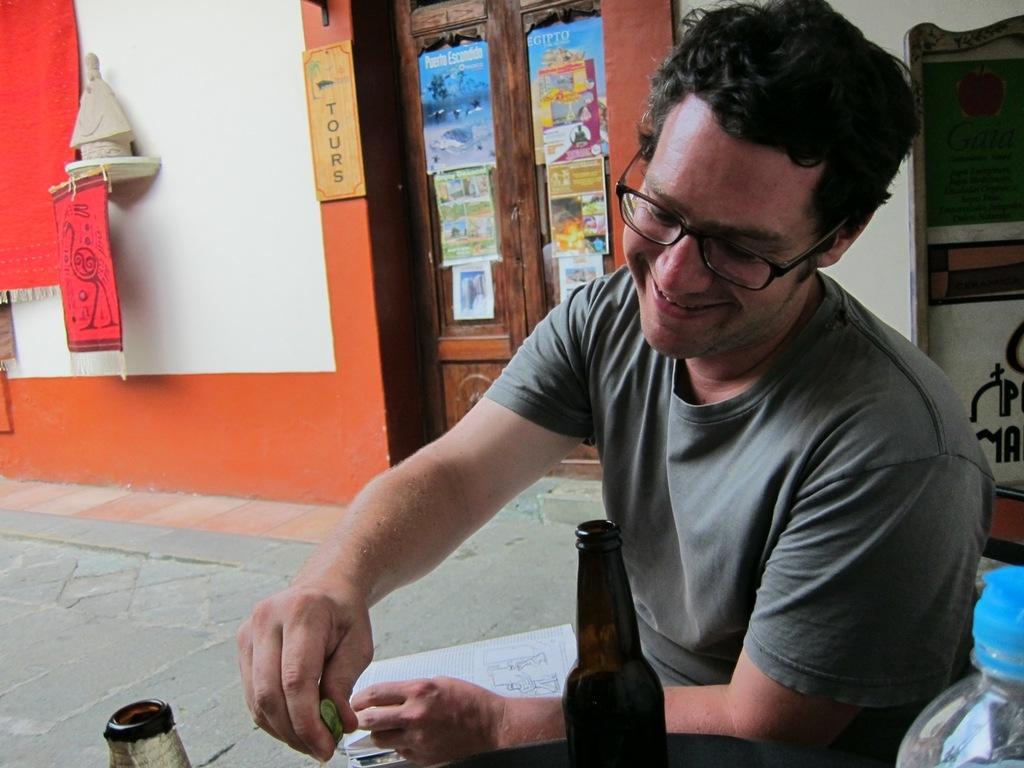How would you summarize this image in a sentence or two? In this picture there is a man sitting on the floor, smiling and wearing spectacles in front of him. There is a bottles placed on the table. In the background there is a wall and a door to which some papers were stuck. 